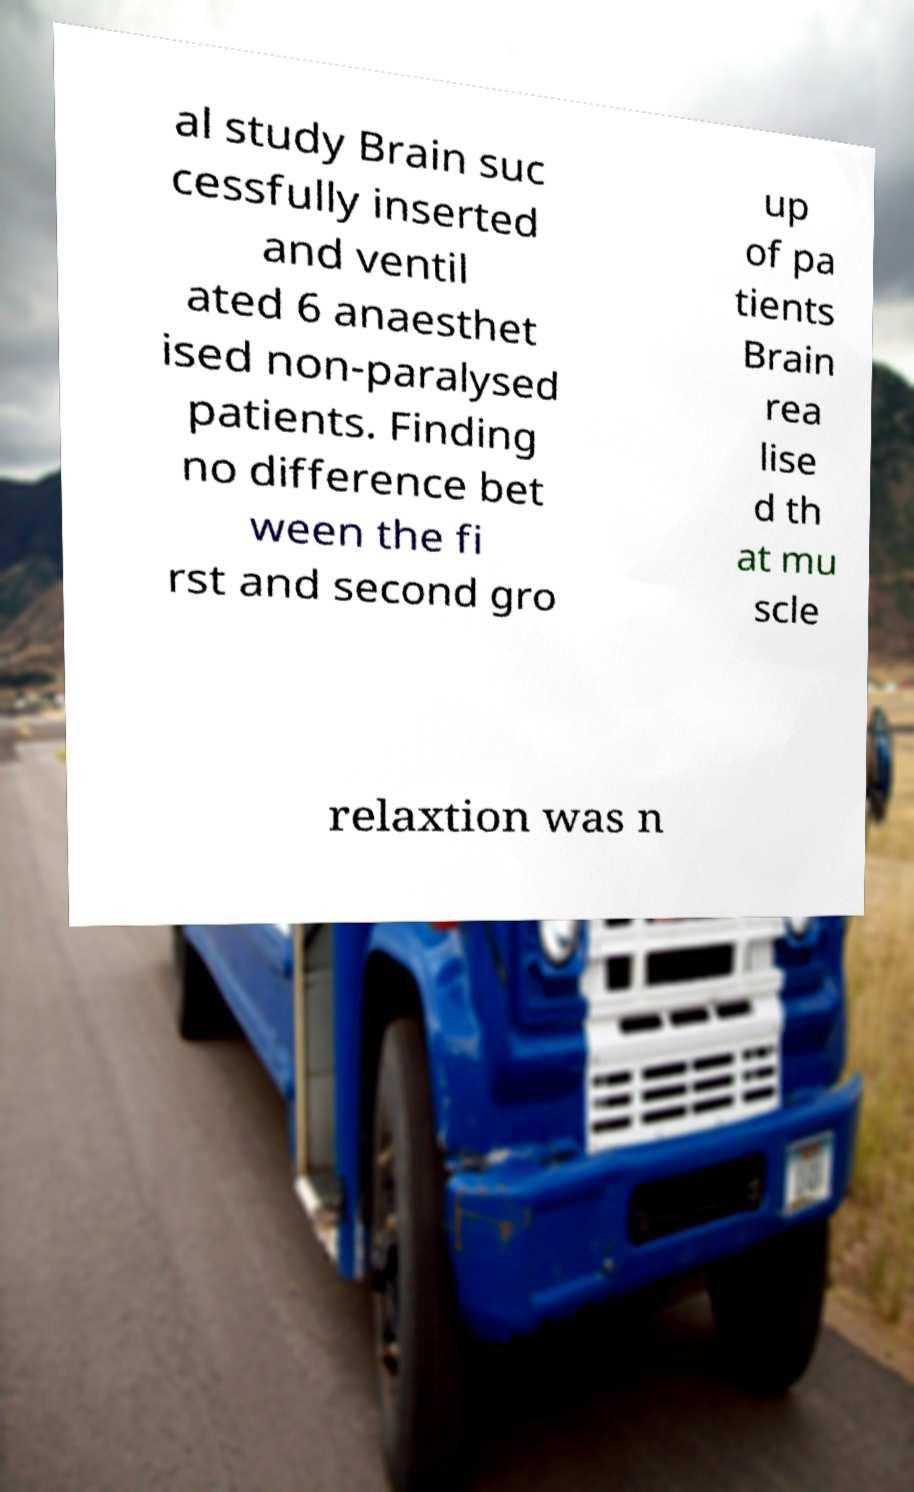What messages or text are displayed in this image? I need them in a readable, typed format. al study Brain suc cessfully inserted and ventil ated 6 anaesthet ised non-paralysed patients. Finding no difference bet ween the fi rst and second gro up of pa tients Brain rea lise d th at mu scle relaxtion was n 